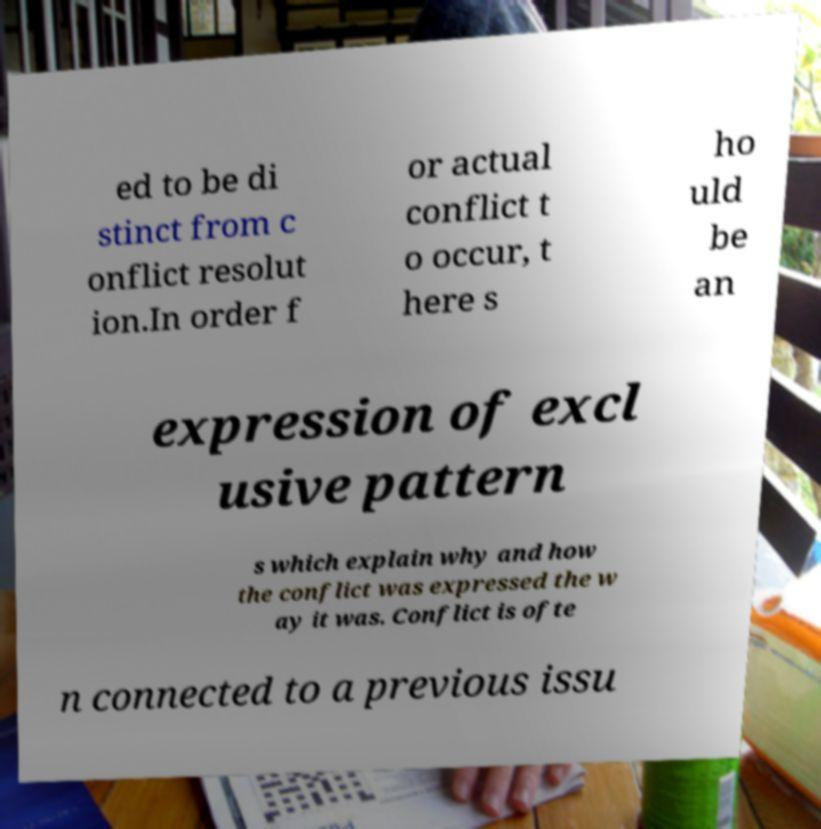Could you assist in decoding the text presented in this image and type it out clearly? ed to be di stinct from c onflict resolut ion.In order f or actual conflict t o occur, t here s ho uld be an expression of excl usive pattern s which explain why and how the conflict was expressed the w ay it was. Conflict is ofte n connected to a previous issu 